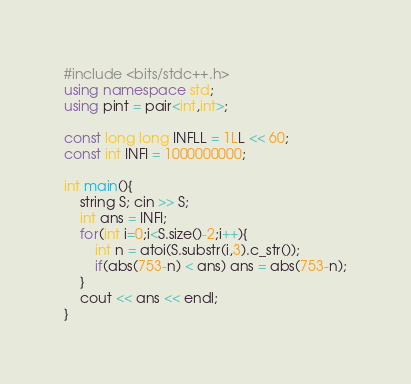Convert code to text. <code><loc_0><loc_0><loc_500><loc_500><_C++_>#include <bits/stdc++.h>
using namespace std;
using pint = pair<int,int>;

const long long INFLL = 1LL << 60;
const int INFI = 1000000000;

int main(){
    string S; cin >> S;
    int ans = INFI;
    for(int i=0;i<S.size()-2;i++){
        int n = atoi(S.substr(i,3).c_str());
        if(abs(753-n) < ans) ans = abs(753-n);
    }
    cout << ans << endl;
}
</code> 